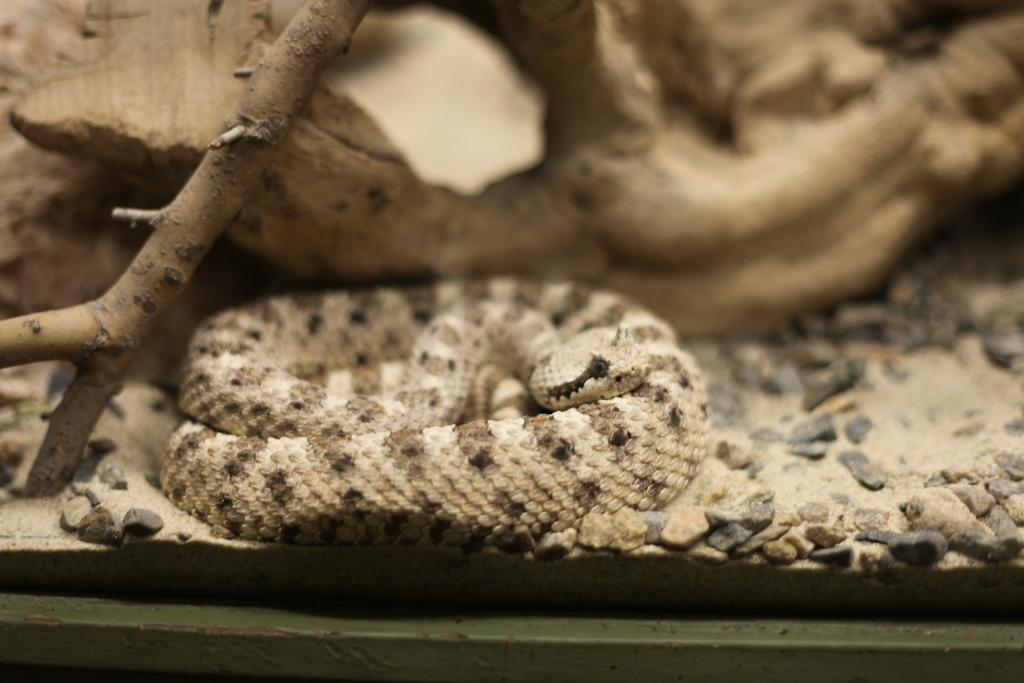What type of animal is in the image? There is a snake in the image. What other objects can be seen in the image? There is a rock, many small stones, and a stick in the image. What books are the students carrying on their way to school in the image? There are no books or students present in the image; it only features a snake, a rock, small stones, and a stick. 